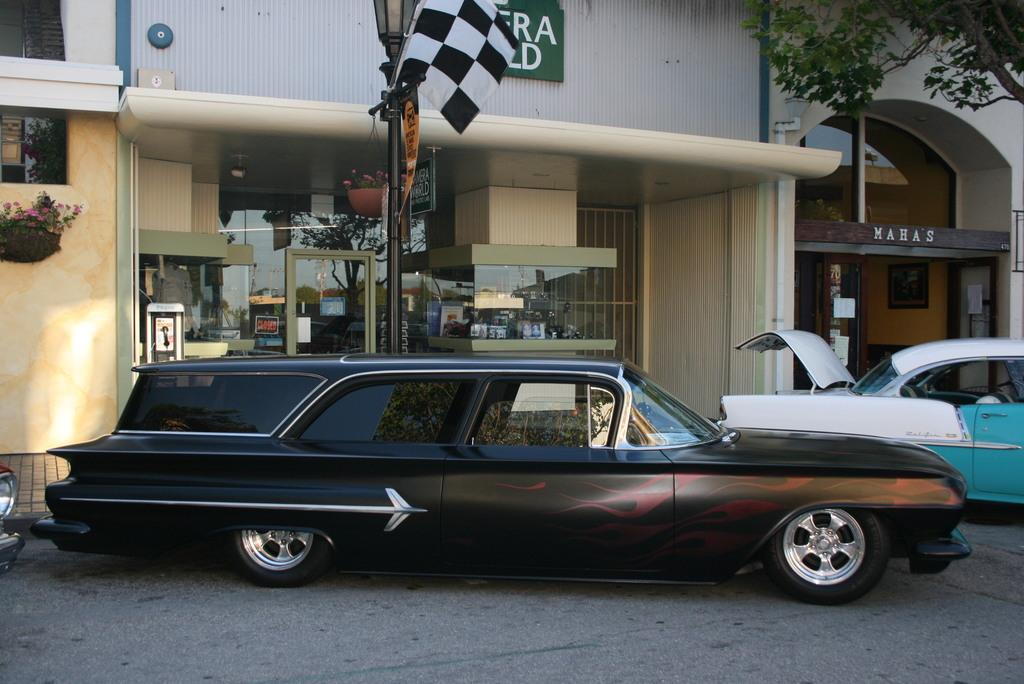What can be seen on the road in the image? There are vehicles on the road in the image. What structures are visible in the image? There are buildings in the image. Can you describe the lighting source in the image? There is a light with a pole in the image. What type of vegetation is present in the image? There are plants in the image. What objects are displayed on the boards in the image? The facts do not specify what is on the boards, so we cannot answer that question definitively. What is the flag attached to in the image? The flag is attached to a pole in the image. What type of tree is visible in the image? There is a tree in the image. How many apples are hanging from the tree in the image? There are no apples present in the image; it features a tree without any fruit. Can you describe the hen sitting on the boards in the image? There is no hen present in the image; it only features boards without any animals. 